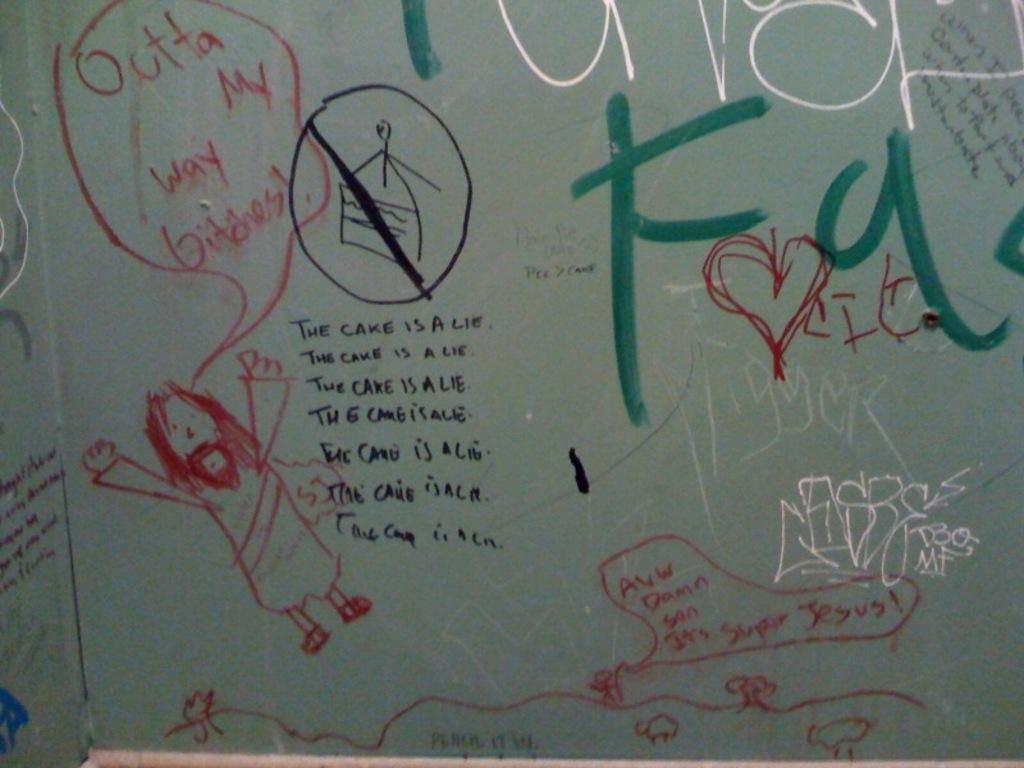What is present on the wall in the image? There are drawings and text on the wall in the image. Can you describe the drawings on the wall? Unfortunately, the specific details of the drawings cannot be determined from the provided facts. What type of text is present on the wall? The type of text on the wall cannot be determined from the provided facts. Can you see a spy hiding behind the wall in the image? There is no mention of a spy or any hidden figures in the provided facts, so it cannot be determined if a spy is present in the image. 